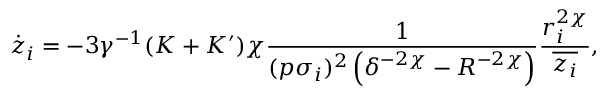<formula> <loc_0><loc_0><loc_500><loc_500>\dot { z } _ { i } = - 3 \gamma ^ { - 1 } ( K + K ^ { \prime } ) \chi \frac { 1 } { ( p \sigma _ { i } ) ^ { 2 } \left ( \delta ^ { - 2 \chi } - R ^ { - 2 \chi } \right ) } \frac { r _ { i } ^ { 2 \chi } } { \overline { { z _ { i } } } } ,</formula> 